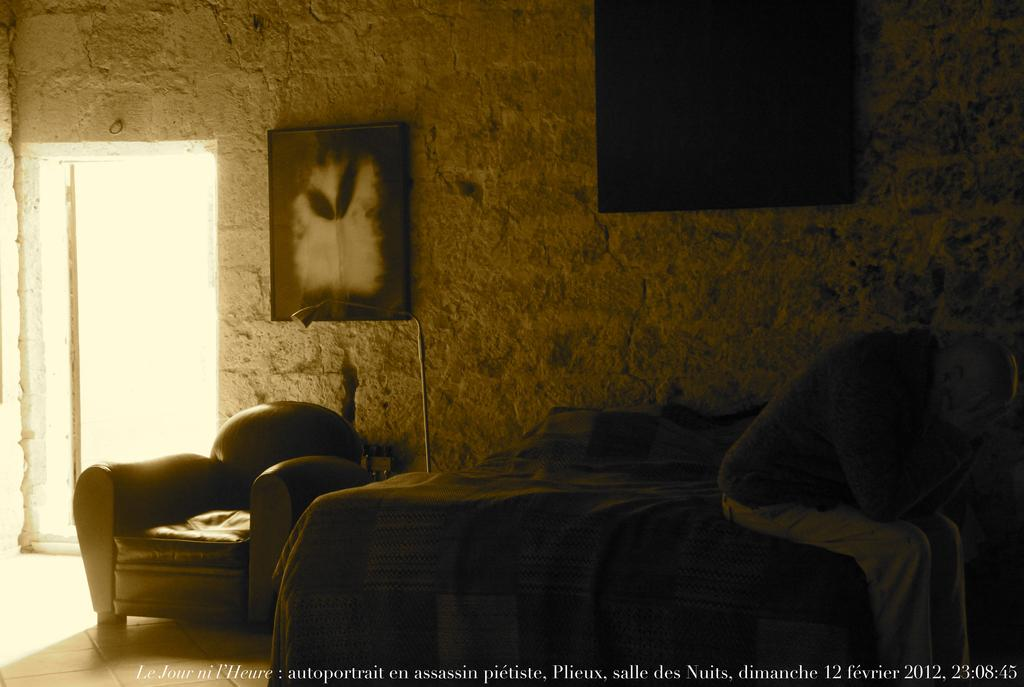What is the person in the image doing? The person is sitting on a bed in the image. What furniture is located beside the bed? There is a black couch beside the bed. What can be seen on the wall in the image? There are photos on the wall in the image. What type of disgust can be seen on the person's face in the image? There is no indication of disgust on the person's face in the image. 